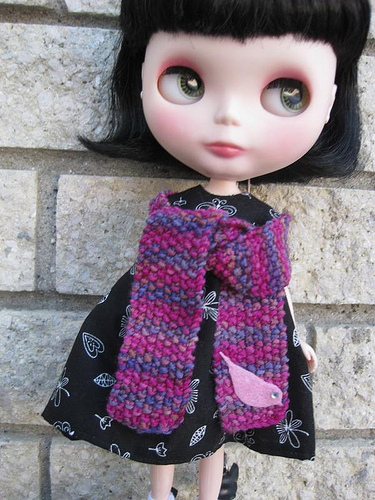<image>
Is there a doll in the wall? No. The doll is not contained within the wall. These objects have a different spatial relationship. 